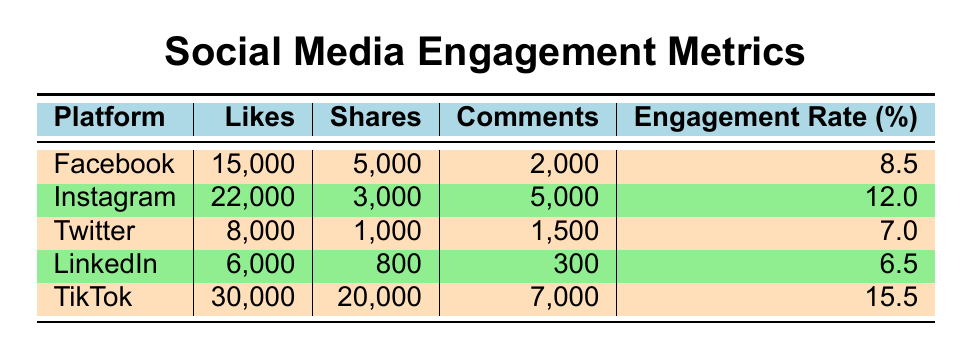What platform has the highest number of likes? By checking the "Likes" column in the table, we can see that TikTok has 30,000 likes, which is higher than any other platform listed.
Answer: TikTok Which platform has the lowest post engagement rate? Looking at the "Engagement Rate" column, LinkedIn has the lowest value at 6.5%.
Answer: LinkedIn How many total likes are there across all platforms? We sum the likes from each platform: 15,000 (Facebook) + 22,000 (Instagram) + 8,000 (Twitter) + 6,000 (LinkedIn) + 30,000 (TikTok) = 81,000.
Answer: 81,000 Is the engagement rate for Instagram higher than that of Facebook? By comparing the "Engagement Rate" values, Instagram has a rate of 12.0% while Facebook has 8.5%, so yes, Instagram's engagement rate is higher.
Answer: Yes What is the average number of shares across all platforms? To find the average number of shares, we take the sum of shares: 5,000 (Facebook) + 3,000 (Instagram) + 1,000 (Twitter) + 800 (LinkedIn) + 20,000 (TikTok) = 29,800. Since there are 5 platforms, we divide 29,800 by 5, which equals 5,960.
Answer: 5,960 Which platform has more shares than comments? We compare the "Shares" and "Comments" for each platform. TikTok (20,000 shares vs. 7,000 comments), Facebook (5,000 shares vs. 2,000 comments), and Instagram (3,000 shares vs. 5,000 comments) show that both TikTok and Facebook have shares greater than their comments.
Answer: TikTok and Facebook What is the difference in likes between TikTok and Twitter? The likes for TikTok are 30,000, and for Twitter, they are 8,000. The difference is calculated as 30,000 - 8,000 = 22,000.
Answer: 22,000 Does any platform have more than 20,000 likes and a post engagement rate of more than 10%? Checking the platforms with likes over 20,000: Instagram has 22,000 likes (12.0% engagement rate), and TikTok has 30,000 likes (15.5% engagement rate). Both match the criteria.
Answer: Yes Which platform's comments are exactly half of its likes? We analyze each platform: Facebook has 2,000 comments (13.3% of likes), Instagram has 5,000 comments (22.7% of likes), Twitter has 1,500 comments (18.8% of likes), LinkedIn has 300 comments (5% of likes), and TikTok has 7,000 comments (23.3% of likes). None matches the condition of having comments equal to half of its likes.
Answer: None 